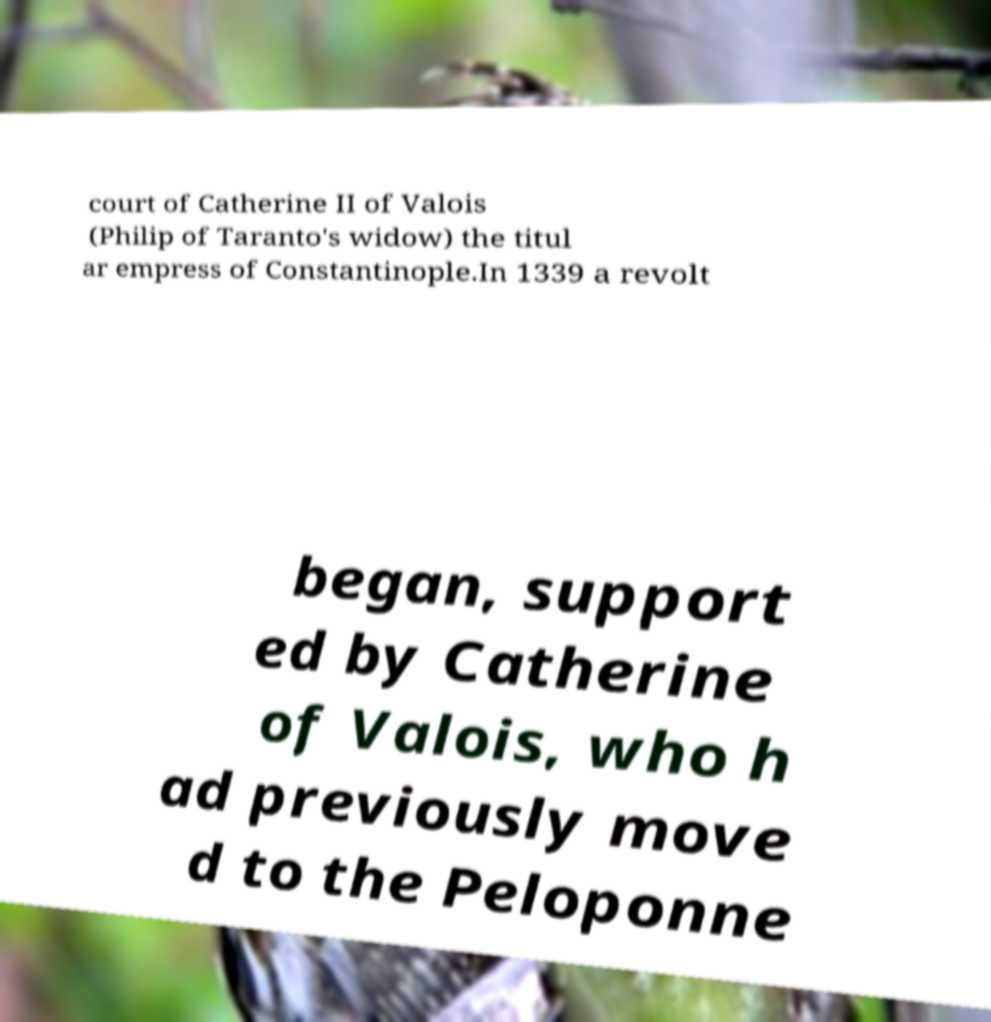For documentation purposes, I need the text within this image transcribed. Could you provide that? court of Catherine II of Valois (Philip of Taranto's widow) the titul ar empress of Constantinople.In 1339 a revolt began, support ed by Catherine of Valois, who h ad previously move d to the Peloponne 